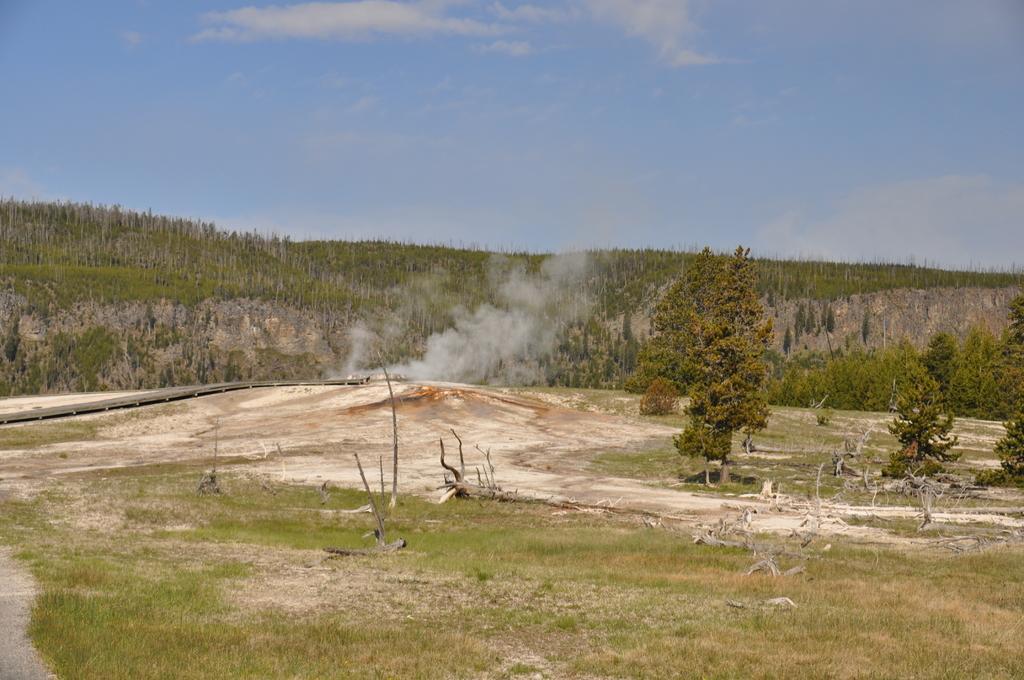How would you summarize this image in a sentence or two? At the bottom of the picture, we see the grass. In the middle, we see the fallen trees. On the right side, we see the trees. There are trees in the background. At the top, we see the sky and the clouds. 